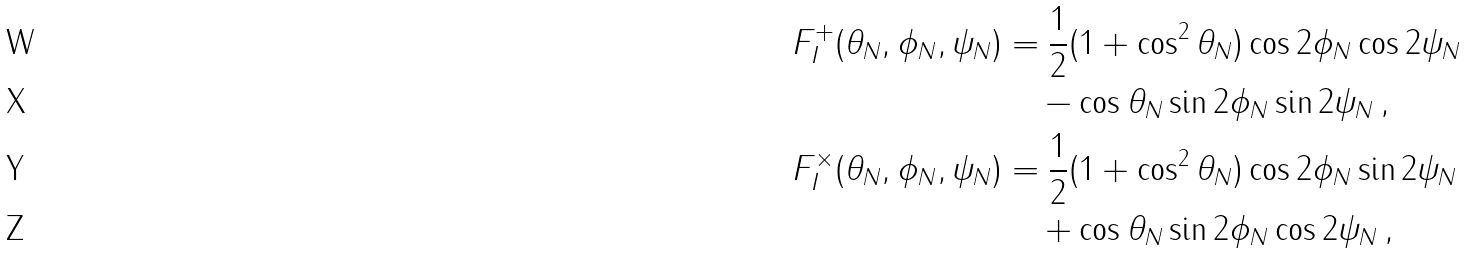Convert formula to latex. <formula><loc_0><loc_0><loc_500><loc_500>F ^ { + } _ { I } ( \theta _ { N } , \phi _ { N } , \psi _ { N } ) & = \frac { 1 } { 2 } ( 1 + \cos ^ { 2 } \theta _ { N } ) \cos 2 \phi _ { N } \cos 2 \psi _ { N } \\ & \quad - \cos \theta _ { N } \sin 2 \phi _ { N } \sin 2 \psi _ { N } \, , \\ F ^ { \times } _ { I } ( \theta _ { N } , \phi _ { N } , \psi _ { N } ) & = \frac { 1 } { 2 } ( 1 + \cos ^ { 2 } \theta _ { N } ) \cos 2 \phi _ { N } \sin 2 \psi _ { N } \\ & \quad + \cos \theta _ { N } \sin 2 \phi _ { N } \cos 2 \psi _ { N } \, ,</formula> 